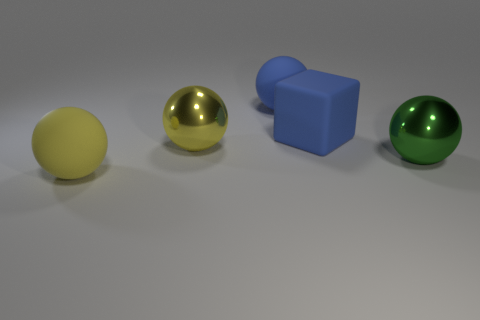What is the material of the green sphere that is right of the large blue matte cube?
Make the answer very short. Metal. There is a big green metallic thing that is right of the big blue sphere; is it the same shape as the object in front of the large green metal thing?
Your response must be concise. Yes. Is the number of green objects right of the green object the same as the number of metal objects?
Offer a terse response. No. How many things have the same material as the big blue block?
Provide a succinct answer. 2. The large block that is the same material as the blue sphere is what color?
Make the answer very short. Blue. Does the green sphere have the same size as the metal ball that is behind the green ball?
Offer a terse response. Yes. The green object is what shape?
Offer a terse response. Sphere. How many metal spheres have the same color as the rubber block?
Make the answer very short. 0. There is another large shiny object that is the same shape as the large yellow metallic thing; what color is it?
Offer a very short reply. Green. How many metallic objects are behind the object that is to the right of the large matte block?
Offer a terse response. 1. 